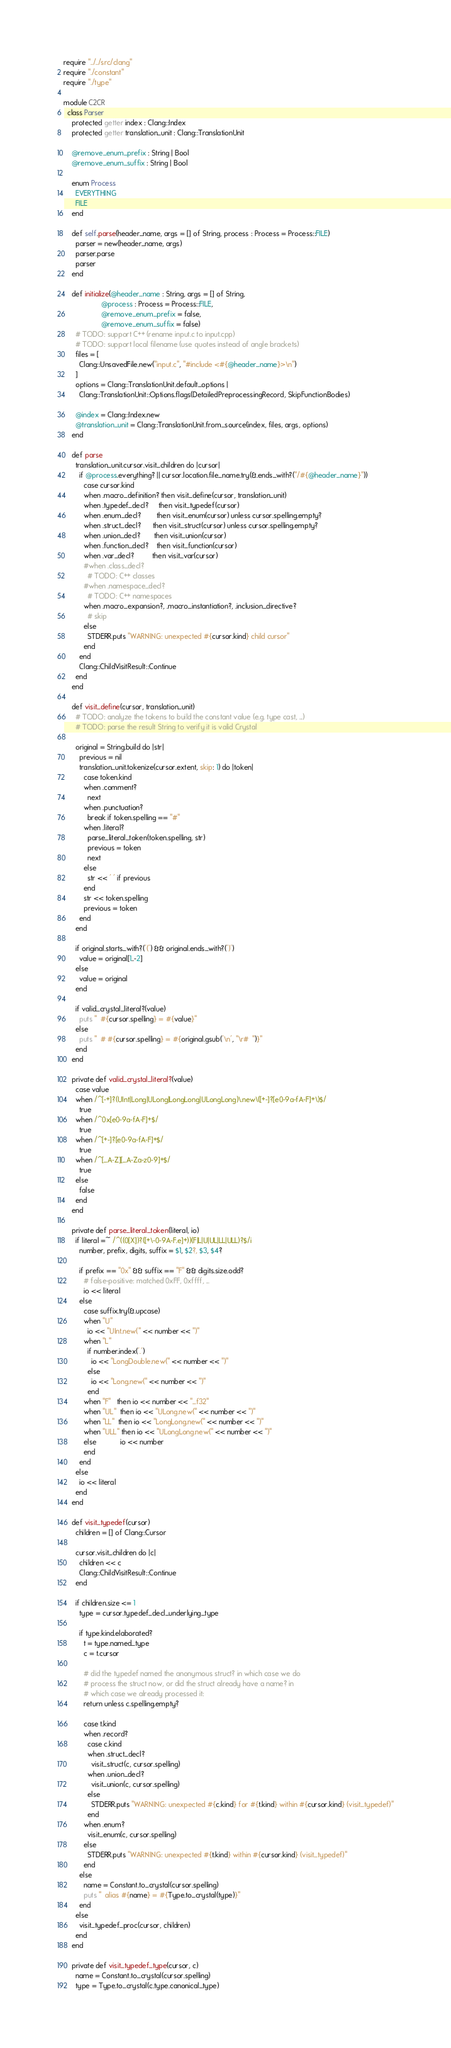<code> <loc_0><loc_0><loc_500><loc_500><_Crystal_>require "../../src/clang"
require "./constant"
require "./type"

module C2CR
  class Parser
    protected getter index : Clang::Index
    protected getter translation_unit : Clang::TranslationUnit

    @remove_enum_prefix : String | Bool
    @remove_enum_suffix : String | Bool

    enum Process
      EVERYTHING
      FILE
    end

    def self.parse(header_name, args = [] of String, process : Process = Process::FILE)
      parser = new(header_name, args)
      parser.parse
      parser
    end

    def initialize(@header_name : String, args = [] of String,
                   @process : Process = Process::FILE,
                   @remove_enum_prefix = false,
                   @remove_enum_suffix = false)
      # TODO: support C++ (rename input.c to input.cpp)
      # TODO: support local filename (use quotes instead of angle brackets)
      files = [
        Clang::UnsavedFile.new("input.c", "#include <#{@header_name}>\n")
      ]
      options = Clang::TranslationUnit.default_options |
        Clang::TranslationUnit::Options.flags(DetailedPreprocessingRecord, SkipFunctionBodies)

      @index = Clang::Index.new
      @translation_unit = Clang::TranslationUnit.from_source(index, files, args, options)
    end

    def parse
      translation_unit.cursor.visit_children do |cursor|
        if @process.everything? || cursor.location.file_name.try(&.ends_with?("/#{@header_name}"))
          case cursor.kind
          when .macro_definition? then visit_define(cursor, translation_unit)
          when .typedef_decl?     then visit_typedef(cursor)
          when .enum_decl?        then visit_enum(cursor) unless cursor.spelling.empty?
          when .struct_decl?      then visit_struct(cursor) unless cursor.spelling.empty?
          when .union_decl?       then visit_union(cursor)
          when .function_decl?    then visit_function(cursor)
          when .var_decl?         then visit_var(cursor)
          #when .class_decl?
            # TODO: C++ classes
          #when .namespace_decl?
            # TODO: C++ namespaces
          when .macro_expansion?, .macro_instantiation?, .inclusion_directive?
            # skip
          else
            STDERR.puts "WARNING: unexpected #{cursor.kind} child cursor"
          end
        end
        Clang::ChildVisitResult::Continue
      end
    end

    def visit_define(cursor, translation_unit)
      # TODO: analyze the tokens to build the constant value (e.g. type cast, ...)
      # TODO: parse the result String to verify it is valid Crystal

      original = String.build do |str|
        previous = nil
        translation_unit.tokenize(cursor.extent, skip: 1) do |token|
          case token.kind
          when .comment?
            next
          when .punctuation?
            break if token.spelling == "#"
          when .literal?
            parse_literal_token(token.spelling, str)
            previous = token
            next
          else
            str << ' ' if previous
          end
          str << token.spelling
          previous = token
        end
      end

      if original.starts_with?('(') && original.ends_with?(')')
        value = original[1..-2]
      else
        value = original
      end

      if valid_crystal_literal?(value)
        puts "  #{cursor.spelling} = #{value}"
      else
        puts "  # #{cursor.spelling} = #{original.gsub('\n', "\r#  ")}"
      end
    end

    private def valid_crystal_literal?(value)
      case value
      when /^[-+]?(UInt|Long|ULong|LongLong|ULongLong)\.new\([+-]?[e0-9a-fA-F]+\)$/
        true
      when /^0x[e0-9a-fA-F]+$/
        true
      when /^[+-]?[e0-9a-fA-F]+$/
        true
      when /^[_A-Z][_A-Za-z0-9]+$/
        true
      else
        false
      end
    end

    private def parse_literal_token(literal, io)
      if literal =~ /^((0[X])?([+\-0-9A-F.e]+))(F|L|U|UL|LL|ULL)?$/i
        number, prefix, digits, suffix = $1, $2?, $3, $4?

        if prefix == "0x" && suffix == "F" && digits.size.odd?
          # false-positive: matched 0xFF, 0xffff, ...
          io << literal
        else
          case suffix.try(&.upcase)
          when "U"
            io << "UInt.new(" << number << ")"
          when "L"
            if number.index('.')
              io << "LongDouble.new(" << number << ")"
            else
              io << "Long.new(" << number << ")"
            end
          when "F"   then io << number << "_f32"
          when "UL"  then io << "ULong.new(" << number << ")"
          when "LL"  then io << "LongLong.new(" << number << ")"
          when "ULL" then io << "ULongLong.new(" << number << ")"
          else            io << number
          end
        end
      else
        io << literal
      end
    end

    def visit_typedef(cursor)
      children = [] of Clang::Cursor

      cursor.visit_children do |c|
        children << c
        Clang::ChildVisitResult::Continue
      end

      if children.size <= 1
        type = cursor.typedef_decl_underlying_type

        if type.kind.elaborated?
          t = type.named_type
          c = t.cursor

          # did the typedef named the anonymous struct? in which case we do
          # process the struct now, or did the struct already have a name? in
          # which case we already processed it:
          return unless c.spelling.empty?

          case t.kind
          when .record?
            case c.kind
            when .struct_decl?
              visit_struct(c, cursor.spelling)
            when .union_decl?
              visit_union(c, cursor.spelling)
            else
              STDERR.puts "WARNING: unexpected #{c.kind} for #{t.kind} within #{cursor.kind} (visit_typedef)"
            end
          when .enum?
            visit_enum(c, cursor.spelling)
          else
            STDERR.puts "WARNING: unexpected #{t.kind} within #{cursor.kind} (visit_typedef)"
          end
        else
          name = Constant.to_crystal(cursor.spelling)
          puts "  alias #{name} = #{Type.to_crystal(type)}"
        end
      else
        visit_typedef_proc(cursor, children)
      end
    end

    private def visit_typedef_type(cursor, c)
      name = Constant.to_crystal(cursor.spelling)
      type = Type.to_crystal(c.type.canonical_type)</code> 